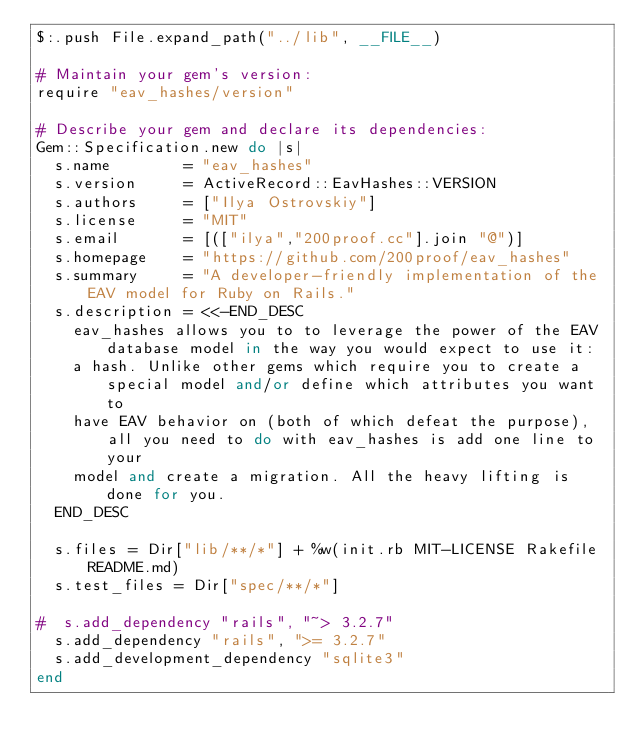Convert code to text. <code><loc_0><loc_0><loc_500><loc_500><_Ruby_>$:.push File.expand_path("../lib", __FILE__)

# Maintain your gem's version:
require "eav_hashes/version"

# Describe your gem and declare its dependencies:
Gem::Specification.new do |s|
  s.name        = "eav_hashes"
  s.version     = ActiveRecord::EavHashes::VERSION
  s.authors     = ["Ilya Ostrovskiy"]
  s.license     = "MIT"
  s.email       = [(["ilya","200proof.cc"].join "@")]
  s.homepage    = "https://github.com/200proof/eav_hashes"
  s.summary     = "A developer-friendly implementation of the EAV model for Ruby on Rails."
  s.description = <<-END_DESC
    eav_hashes allows you to to leverage the power of the EAV database model in the way you would expect to use it:
    a hash. Unlike other gems which require you to create a special model and/or define which attributes you want to
    have EAV behavior on (both of which defeat the purpose), all you need to do with eav_hashes is add one line to your
    model and create a migration. All the heavy lifting is done for you.
  END_DESC

  s.files = Dir["lib/**/*"] + %w(init.rb MIT-LICENSE Rakefile README.md)
  s.test_files = Dir["spec/**/*"]

#  s.add_dependency "rails", "~> 3.2.7"
  s.add_dependency "rails", ">= 3.2.7"
  s.add_development_dependency "sqlite3"
end
</code> 